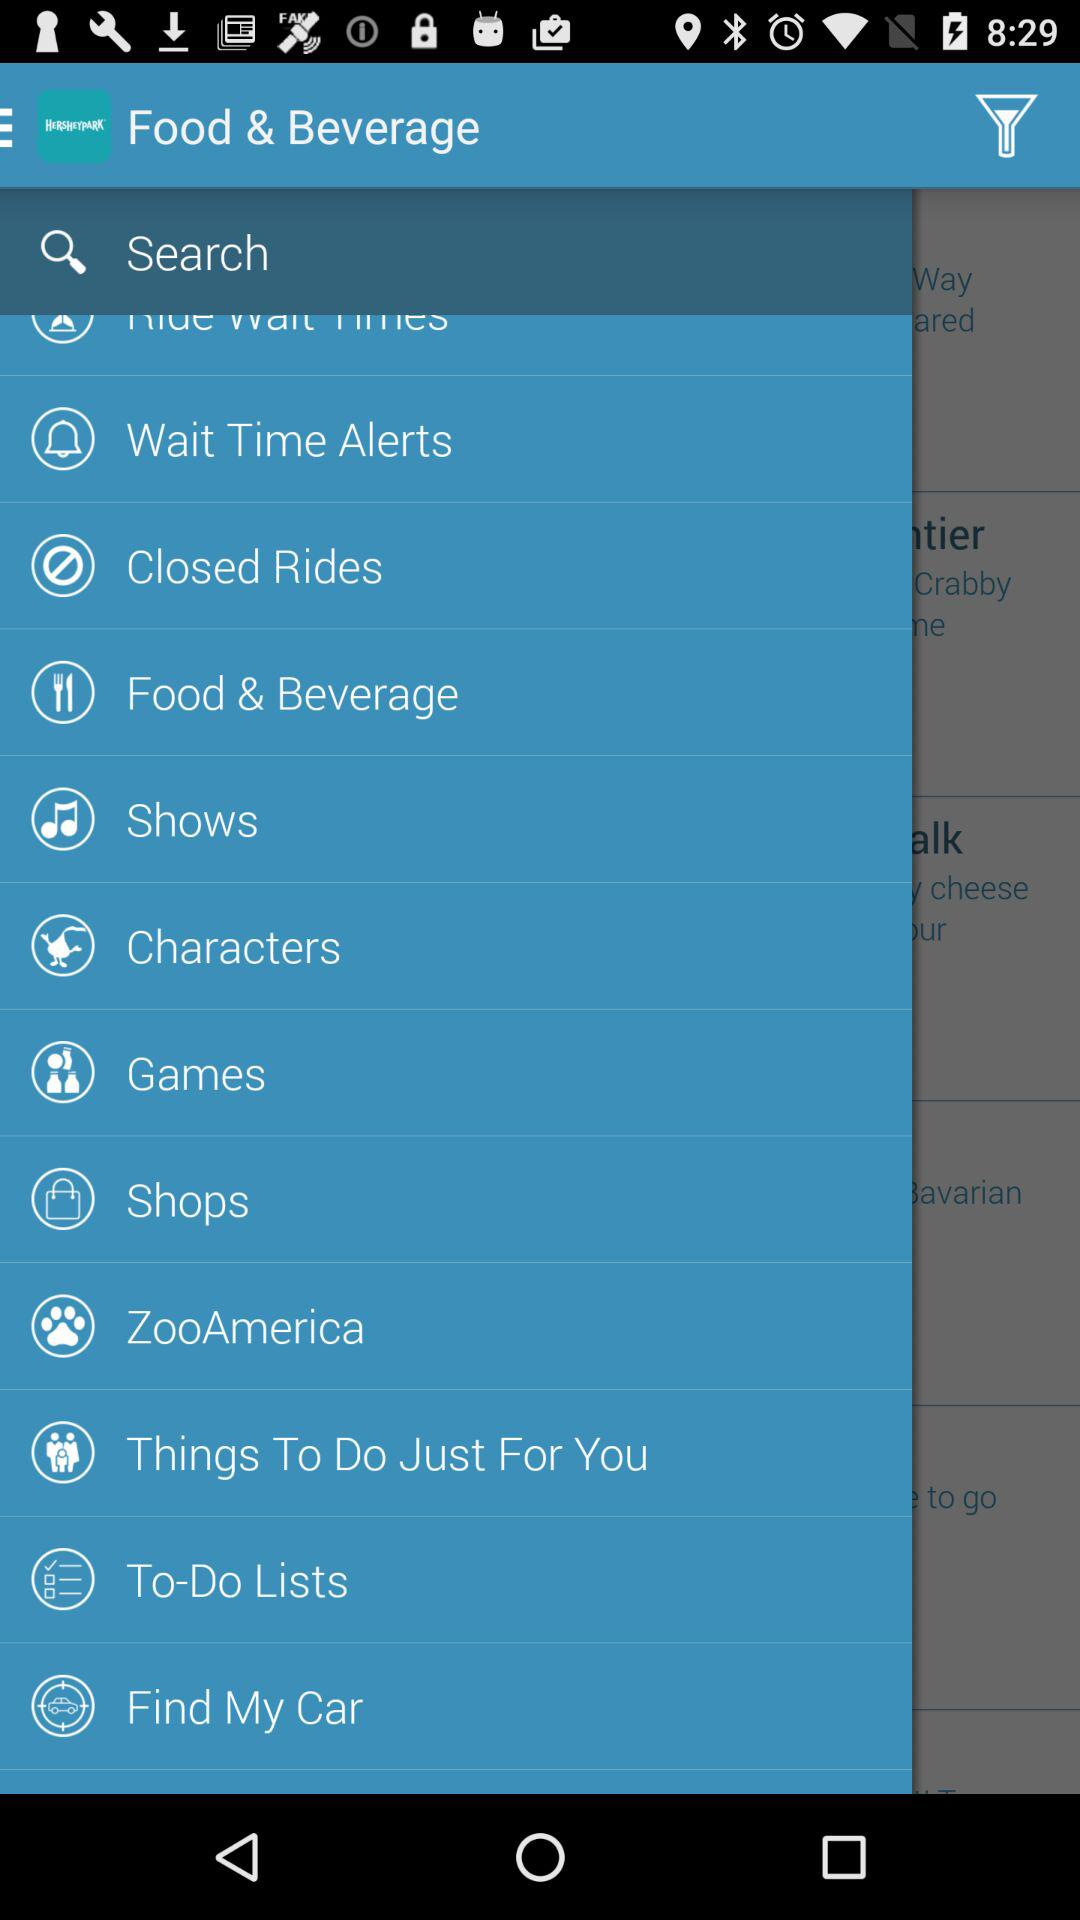What is the application name? The application name is "Hersheypark". 